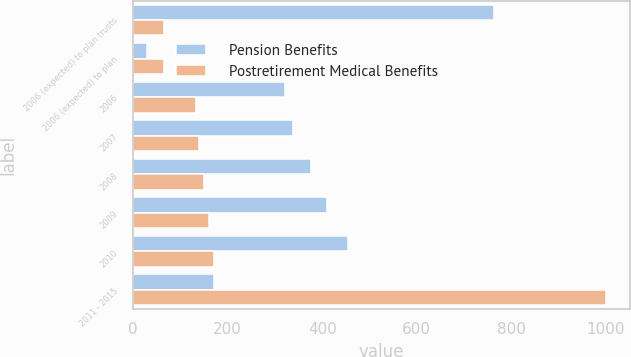Convert chart to OTSL. <chart><loc_0><loc_0><loc_500><loc_500><stacked_bar_chart><ecel><fcel>2006 (expected) to plan trusts<fcel>2006 (expected) to plan<fcel>2006<fcel>2007<fcel>2008<fcel>2009<fcel>2010<fcel>2011 - 2015<nl><fcel>Pension Benefits<fcel>763<fcel>30<fcel>322<fcel>338<fcel>376<fcel>410<fcel>454<fcel>170<nl><fcel>Postretirement Medical Benefits<fcel>65<fcel>65<fcel>132<fcel>140<fcel>149<fcel>160<fcel>170<fcel>1000<nl></chart> 